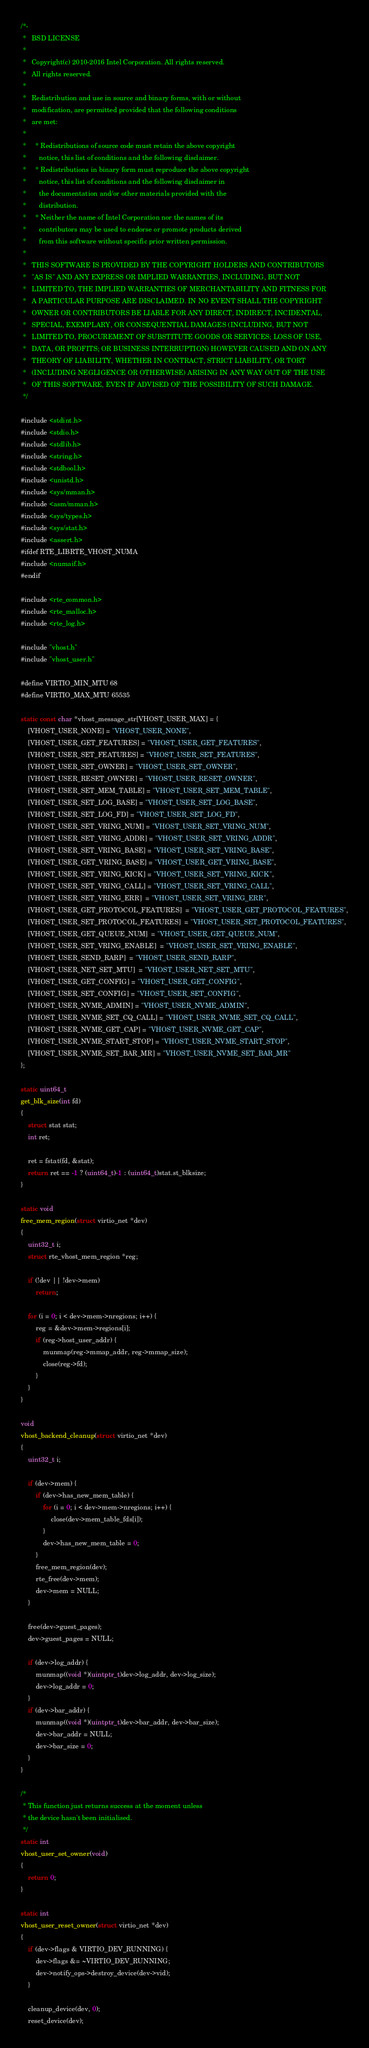<code> <loc_0><loc_0><loc_500><loc_500><_C_>/*-
 *   BSD LICENSE
 *
 *   Copyright(c) 2010-2016 Intel Corporation. All rights reserved.
 *   All rights reserved.
 *
 *   Redistribution and use in source and binary forms, with or without
 *   modification, are permitted provided that the following conditions
 *   are met:
 *
 *     * Redistributions of source code must retain the above copyright
 *       notice, this list of conditions and the following disclaimer.
 *     * Redistributions in binary form must reproduce the above copyright
 *       notice, this list of conditions and the following disclaimer in
 *       the documentation and/or other materials provided with the
 *       distribution.
 *     * Neither the name of Intel Corporation nor the names of its
 *       contributors may be used to endorse or promote products derived
 *       from this software without specific prior written permission.
 *
 *   THIS SOFTWARE IS PROVIDED BY THE COPYRIGHT HOLDERS AND CONTRIBUTORS
 *   "AS IS" AND ANY EXPRESS OR IMPLIED WARRANTIES, INCLUDING, BUT NOT
 *   LIMITED TO, THE IMPLIED WARRANTIES OF MERCHANTABILITY AND FITNESS FOR
 *   A PARTICULAR PURPOSE ARE DISCLAIMED. IN NO EVENT SHALL THE COPYRIGHT
 *   OWNER OR CONTRIBUTORS BE LIABLE FOR ANY DIRECT, INDIRECT, INCIDENTAL,
 *   SPECIAL, EXEMPLARY, OR CONSEQUENTIAL DAMAGES (INCLUDING, BUT NOT
 *   LIMITED TO, PROCUREMENT OF SUBSTITUTE GOODS OR SERVICES; LOSS OF USE,
 *   DATA, OR PROFITS; OR BUSINESS INTERRUPTION) HOWEVER CAUSED AND ON ANY
 *   THEORY OF LIABILITY, WHETHER IN CONTRACT, STRICT LIABILITY, OR TORT
 *   (INCLUDING NEGLIGENCE OR OTHERWISE) ARISING IN ANY WAY OUT OF THE USE
 *   OF THIS SOFTWARE, EVEN IF ADVISED OF THE POSSIBILITY OF SUCH DAMAGE.
 */

#include <stdint.h>
#include <stdio.h>
#include <stdlib.h>
#include <string.h>
#include <stdbool.h>
#include <unistd.h>
#include <sys/mman.h>
#include <asm/mman.h>
#include <sys/types.h>
#include <sys/stat.h>
#include <assert.h>
#ifdef RTE_LIBRTE_VHOST_NUMA
#include <numaif.h>
#endif

#include <rte_common.h>
#include <rte_malloc.h>
#include <rte_log.h>

#include "vhost.h"
#include "vhost_user.h"

#define VIRTIO_MIN_MTU 68
#define VIRTIO_MAX_MTU 65535

static const char *vhost_message_str[VHOST_USER_MAX] = {
	[VHOST_USER_NONE] = "VHOST_USER_NONE",
	[VHOST_USER_GET_FEATURES] = "VHOST_USER_GET_FEATURES",
	[VHOST_USER_SET_FEATURES] = "VHOST_USER_SET_FEATURES",
	[VHOST_USER_SET_OWNER] = "VHOST_USER_SET_OWNER",
	[VHOST_USER_RESET_OWNER] = "VHOST_USER_RESET_OWNER",
	[VHOST_USER_SET_MEM_TABLE] = "VHOST_USER_SET_MEM_TABLE",
	[VHOST_USER_SET_LOG_BASE] = "VHOST_USER_SET_LOG_BASE",
	[VHOST_USER_SET_LOG_FD] = "VHOST_USER_SET_LOG_FD",
	[VHOST_USER_SET_VRING_NUM] = "VHOST_USER_SET_VRING_NUM",
	[VHOST_USER_SET_VRING_ADDR] = "VHOST_USER_SET_VRING_ADDR",
	[VHOST_USER_SET_VRING_BASE] = "VHOST_USER_SET_VRING_BASE",
	[VHOST_USER_GET_VRING_BASE] = "VHOST_USER_GET_VRING_BASE",
	[VHOST_USER_SET_VRING_KICK] = "VHOST_USER_SET_VRING_KICK",
	[VHOST_USER_SET_VRING_CALL] = "VHOST_USER_SET_VRING_CALL",
	[VHOST_USER_SET_VRING_ERR]  = "VHOST_USER_SET_VRING_ERR",
	[VHOST_USER_GET_PROTOCOL_FEATURES]  = "VHOST_USER_GET_PROTOCOL_FEATURES",
	[VHOST_USER_SET_PROTOCOL_FEATURES]  = "VHOST_USER_SET_PROTOCOL_FEATURES",
	[VHOST_USER_GET_QUEUE_NUM]  = "VHOST_USER_GET_QUEUE_NUM",
	[VHOST_USER_SET_VRING_ENABLE]  = "VHOST_USER_SET_VRING_ENABLE",
	[VHOST_USER_SEND_RARP]  = "VHOST_USER_SEND_RARP",
	[VHOST_USER_NET_SET_MTU]  = "VHOST_USER_NET_SET_MTU",
	[VHOST_USER_GET_CONFIG] = "VHOST_USER_GET_CONFIG",
	[VHOST_USER_SET_CONFIG] = "VHOST_USER_SET_CONFIG",
	[VHOST_USER_NVME_ADMIN] = "VHOST_USER_NVME_ADMIN",
	[VHOST_USER_NVME_SET_CQ_CALL] = "VHOST_USER_NVME_SET_CQ_CALL",
	[VHOST_USER_NVME_GET_CAP] = "VHOST_USER_NVME_GET_CAP",
	[VHOST_USER_NVME_START_STOP] = "VHOST_USER_NVME_START_STOP",
	[VHOST_USER_NVME_SET_BAR_MR] = "VHOST_USER_NVME_SET_BAR_MR"
};

static uint64_t
get_blk_size(int fd)
{
	struct stat stat;
	int ret;

	ret = fstat(fd, &stat);
	return ret == -1 ? (uint64_t)-1 : (uint64_t)stat.st_blksize;
}

static void
free_mem_region(struct virtio_net *dev)
{
	uint32_t i;
	struct rte_vhost_mem_region *reg;

	if (!dev || !dev->mem)
		return;

	for (i = 0; i < dev->mem->nregions; i++) {
		reg = &dev->mem->regions[i];
		if (reg->host_user_addr) {
			munmap(reg->mmap_addr, reg->mmap_size);
			close(reg->fd);
		}
	}
}

void
vhost_backend_cleanup(struct virtio_net *dev)
{
	uint32_t i;

	if (dev->mem) {
		if (dev->has_new_mem_table) {
			for (i = 0; i < dev->mem->nregions; i++) {
				close(dev->mem_table_fds[i]);
			}
			dev->has_new_mem_table = 0;
		}
		free_mem_region(dev);
		rte_free(dev->mem);
		dev->mem = NULL;
	}

	free(dev->guest_pages);
	dev->guest_pages = NULL;

	if (dev->log_addr) {
		munmap((void *)(uintptr_t)dev->log_addr, dev->log_size);
		dev->log_addr = 0;
	}
	if (dev->bar_addr) {
		munmap((void *)(uintptr_t)dev->bar_addr, dev->bar_size);
		dev->bar_addr = NULL;
		dev->bar_size = 0;
	}
}

/*
 * This function just returns success at the moment unless
 * the device hasn't been initialised.
 */
static int
vhost_user_set_owner(void)
{
	return 0;
}

static int
vhost_user_reset_owner(struct virtio_net *dev)
{
	if (dev->flags & VIRTIO_DEV_RUNNING) {
		dev->flags &= ~VIRTIO_DEV_RUNNING;
		dev->notify_ops->destroy_device(dev->vid);
	}

	cleanup_device(dev, 0);
	reset_device(dev);</code> 